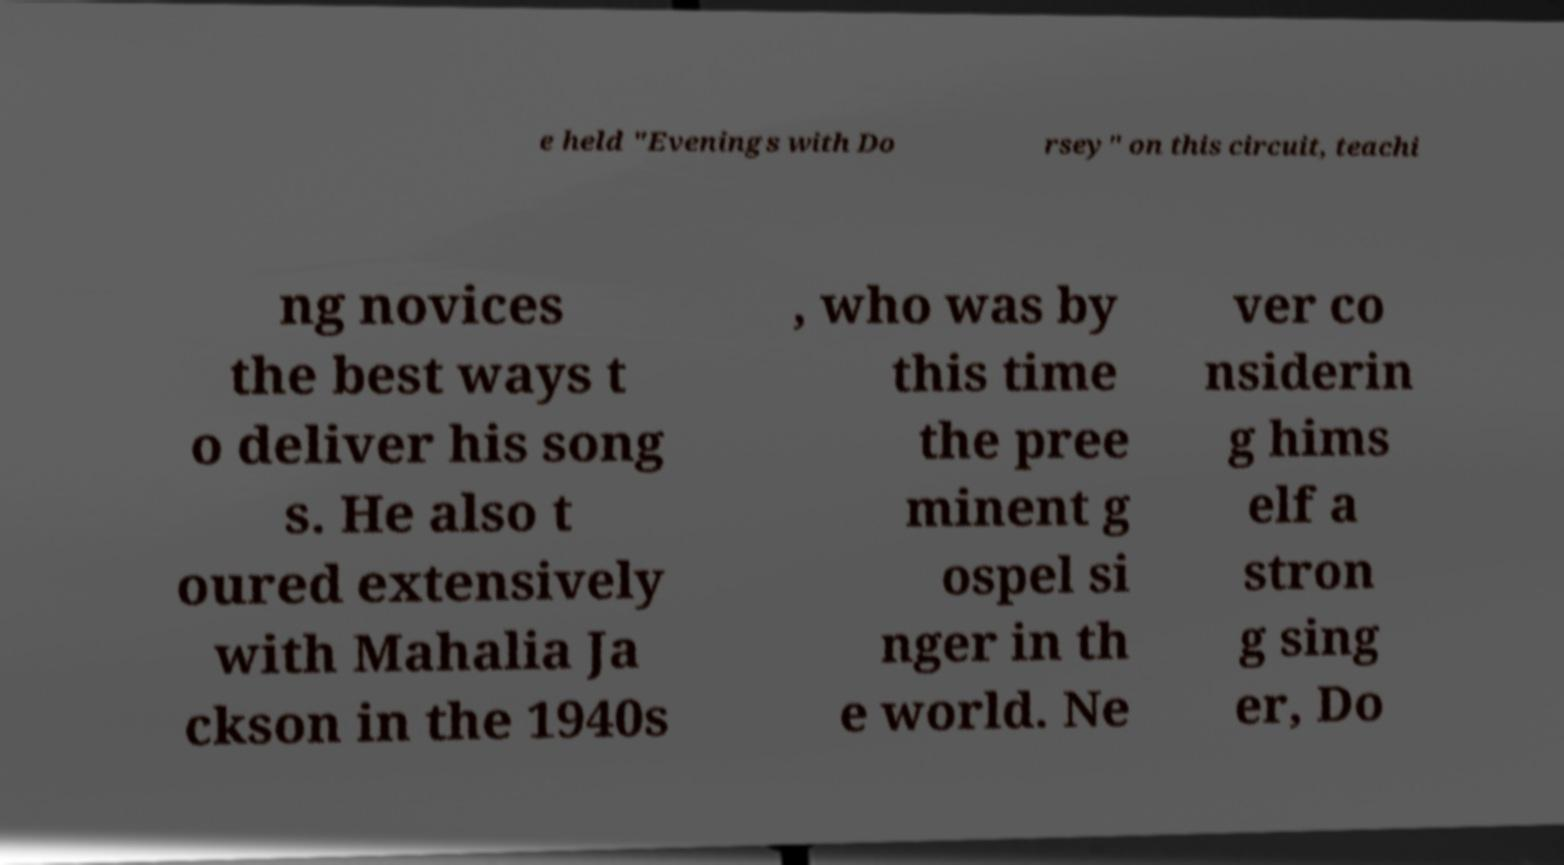Can you accurately transcribe the text from the provided image for me? e held "Evenings with Do rsey" on this circuit, teachi ng novices the best ways t o deliver his song s. He also t oured extensively with Mahalia Ja ckson in the 1940s , who was by this time the pree minent g ospel si nger in th e world. Ne ver co nsiderin g hims elf a stron g sing er, Do 